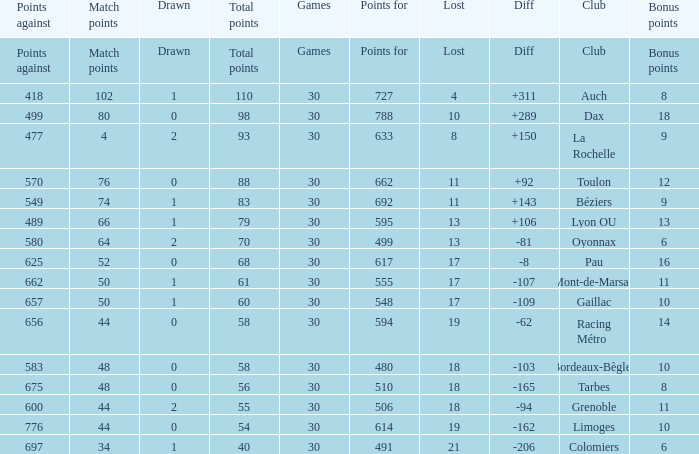What is the amount of match points for a club that lost 18 and has 11 bonus points? 44.0. 